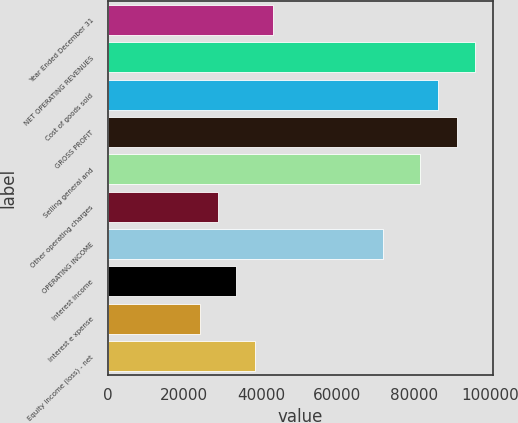Convert chart to OTSL. <chart><loc_0><loc_0><loc_500><loc_500><bar_chart><fcel>Year Ended December 31<fcel>NET OPERATING REVENUES<fcel>Cost of goods sold<fcel>GROSS PROFIT<fcel>Selling general and<fcel>Other operating charges<fcel>OPERATING INCOME<fcel>Interest income<fcel>Interest e xpense<fcel>Equity income (loss) - net<nl><fcel>43215.5<fcel>96032<fcel>86429<fcel>91230.5<fcel>81627.5<fcel>28811<fcel>72024.5<fcel>33612.5<fcel>24009.5<fcel>38414<nl></chart> 